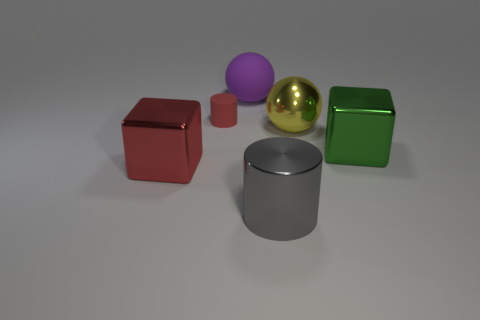There is a gray cylinder; what number of big red metallic objects are on the right side of it?
Your answer should be very brief. 0. Are there any red matte cubes of the same size as the yellow ball?
Offer a very short reply. No. Are there any rubber objects that have the same color as the small rubber cylinder?
Give a very brief answer. No. Are there any other things that have the same size as the yellow sphere?
Your response must be concise. Yes. How many big rubber objects have the same color as the metal cylinder?
Keep it short and to the point. 0. Does the matte cylinder have the same color as the big block that is to the left of the big gray shiny object?
Keep it short and to the point. Yes. What number of objects are either small matte objects or big metallic blocks that are left of the big cylinder?
Your answer should be very brief. 2. There is a metallic object in front of the big cube that is in front of the large green thing; what is its size?
Your answer should be very brief. Large. Is the number of large purple objects in front of the tiny red matte object the same as the number of yellow metal balls that are in front of the large rubber object?
Make the answer very short. No. There is a cylinder behind the large green metallic cube; are there any big purple rubber balls that are in front of it?
Give a very brief answer. No. 